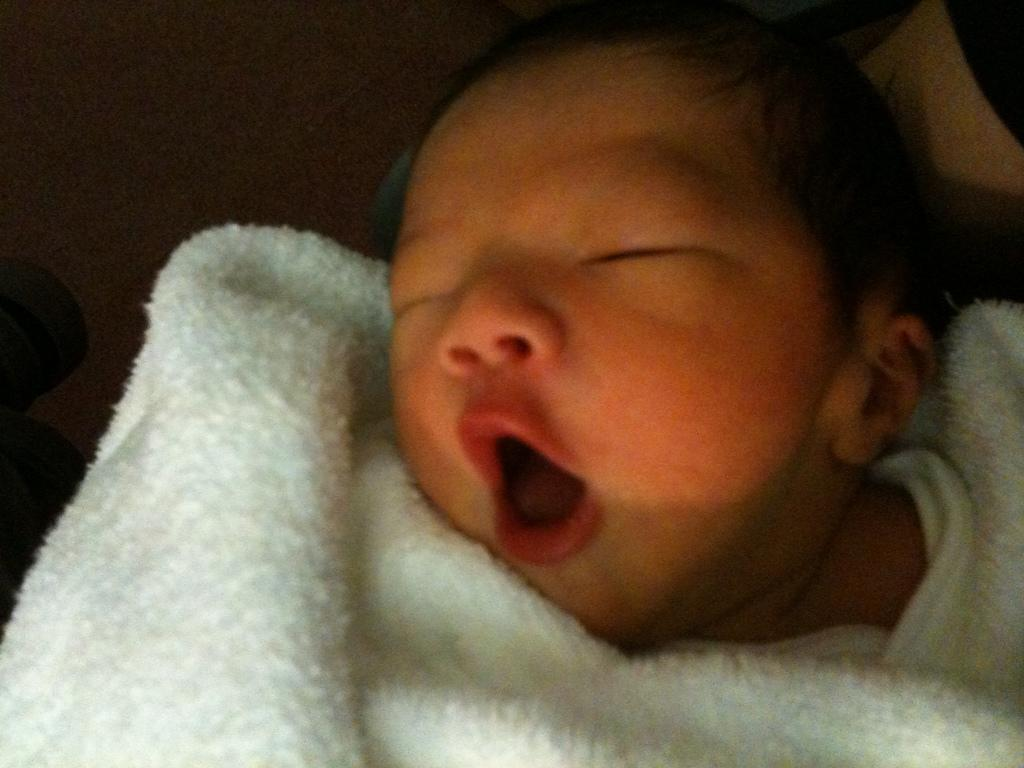What is the main subject of the image? The main subject of the image is a baby. What is the baby doing in the image? The baby is sleeping. What is covering the baby in the image? There is a white color blanket on the baby. What type of meal is being prepared for the baby in the image? There is no meal preparation visible in the image; the baby is sleeping with a white color blanket on them. What decision is the baby making in the image? The baby is sleeping and not making any decisions in the image. 